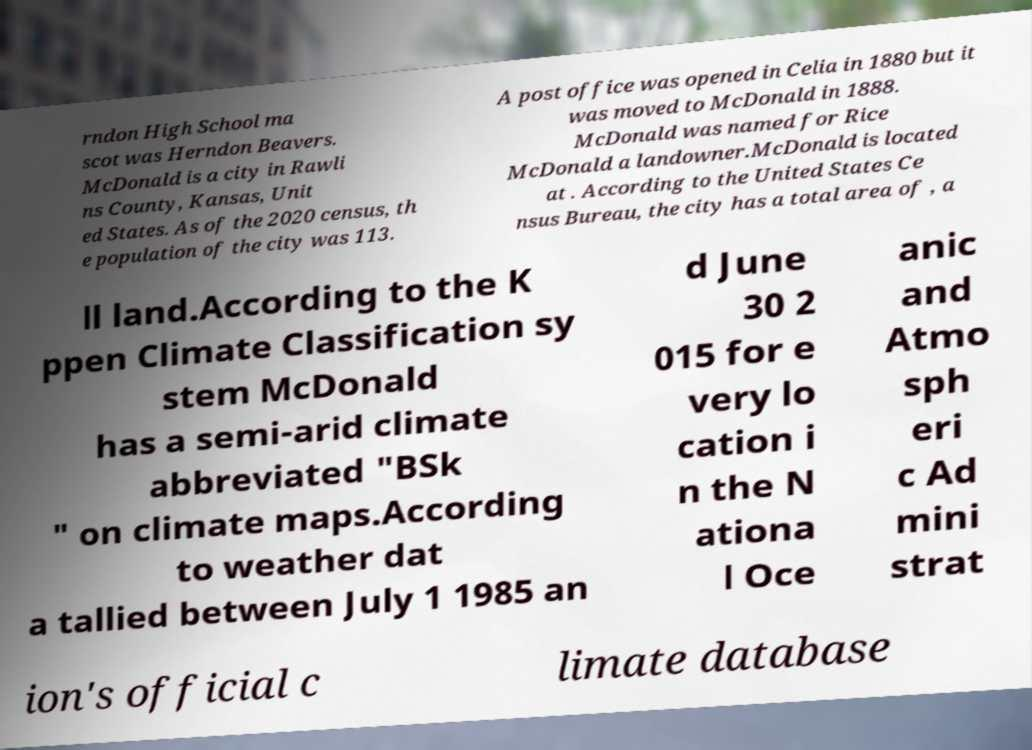Please read and relay the text visible in this image. What does it say? rndon High School ma scot was Herndon Beavers. McDonald is a city in Rawli ns County, Kansas, Unit ed States. As of the 2020 census, th e population of the city was 113. A post office was opened in Celia in 1880 but it was moved to McDonald in 1888. McDonald was named for Rice McDonald a landowner.McDonald is located at . According to the United States Ce nsus Bureau, the city has a total area of , a ll land.According to the K ppen Climate Classification sy stem McDonald has a semi-arid climate abbreviated "BSk " on climate maps.According to weather dat a tallied between July 1 1985 an d June 30 2 015 for e very lo cation i n the N ationa l Oce anic and Atmo sph eri c Ad mini strat ion's official c limate database 